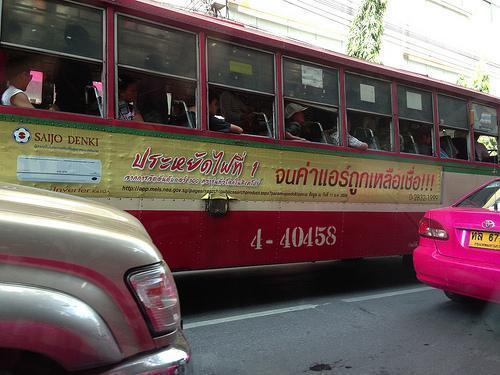How many cars are along side the bus?
Give a very brief answer. 2. 